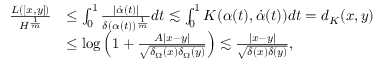Convert formula to latex. <formula><loc_0><loc_0><loc_500><loc_500>\begin{array} { r l } { \frac { L ( [ x , y ] ) } { H ^ { \frac { 1 } { m } } } } & { \leq \int _ { 0 } ^ { 1 } \frac { | \dot { \alpha } ( t ) | } { \delta ( \alpha ( t ) ) ^ { \frac { 1 } { m } } } d t \lesssim \int _ { 0 } ^ { 1 } K ( \alpha ( t ) , \dot { \alpha } ( t ) ) d t = d _ { K } ( x , y ) } \\ & { \leq \log \left ( 1 + \frac { A | x - y | } { \sqrt { \delta _ { \Omega } ( x ) \delta _ { \Omega } ( y ) } } \right ) \lesssim \frac { | x - y | } { \sqrt { \delta ( x ) \delta ( y ) } } , } \end{array}</formula> 